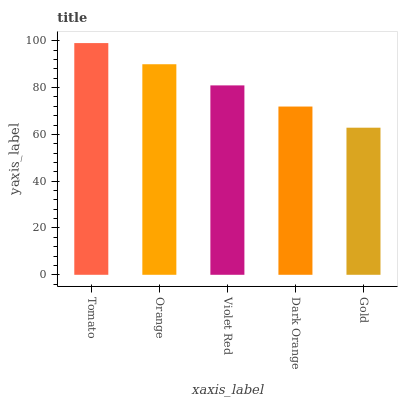Is Orange the minimum?
Answer yes or no. No. Is Orange the maximum?
Answer yes or no. No. Is Tomato greater than Orange?
Answer yes or no. Yes. Is Orange less than Tomato?
Answer yes or no. Yes. Is Orange greater than Tomato?
Answer yes or no. No. Is Tomato less than Orange?
Answer yes or no. No. Is Violet Red the high median?
Answer yes or no. Yes. Is Violet Red the low median?
Answer yes or no. Yes. Is Orange the high median?
Answer yes or no. No. Is Tomato the low median?
Answer yes or no. No. 